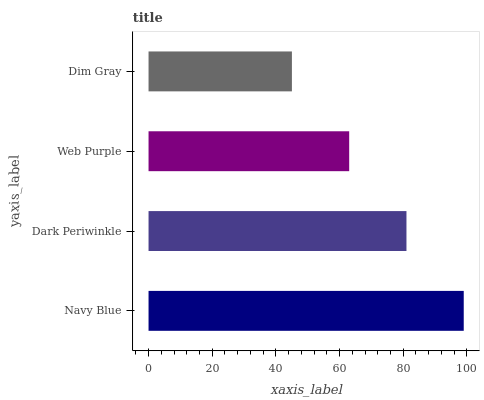Is Dim Gray the minimum?
Answer yes or no. Yes. Is Navy Blue the maximum?
Answer yes or no. Yes. Is Dark Periwinkle the minimum?
Answer yes or no. No. Is Dark Periwinkle the maximum?
Answer yes or no. No. Is Navy Blue greater than Dark Periwinkle?
Answer yes or no. Yes. Is Dark Periwinkle less than Navy Blue?
Answer yes or no. Yes. Is Dark Periwinkle greater than Navy Blue?
Answer yes or no. No. Is Navy Blue less than Dark Periwinkle?
Answer yes or no. No. Is Dark Periwinkle the high median?
Answer yes or no. Yes. Is Web Purple the low median?
Answer yes or no. Yes. Is Web Purple the high median?
Answer yes or no. No. Is Navy Blue the low median?
Answer yes or no. No. 